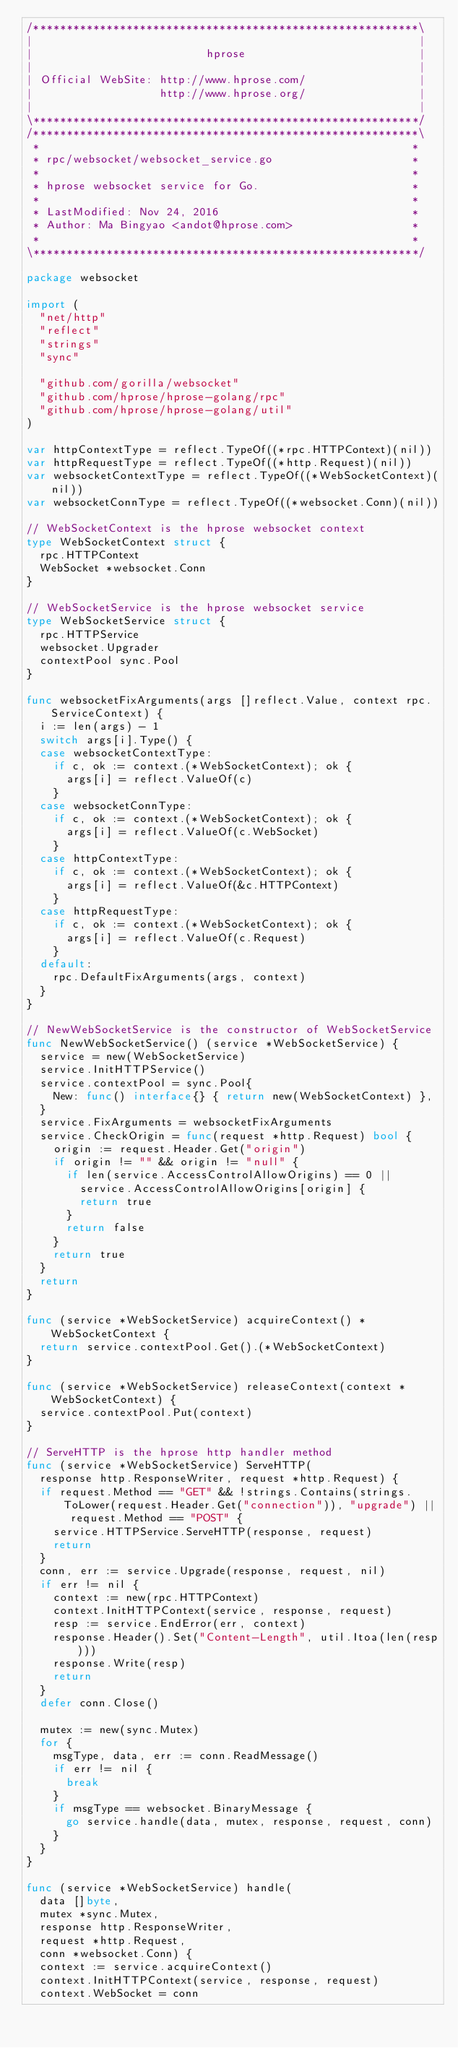<code> <loc_0><loc_0><loc_500><loc_500><_Go_>/**********************************************************\
|                                                          |
|                          hprose                          |
|                                                          |
| Official WebSite: http://www.hprose.com/                 |
|                   http://www.hprose.org/                 |
|                                                          |
\**********************************************************/
/**********************************************************\
 *                                                        *
 * rpc/websocket/websocket_service.go                     *
 *                                                        *
 * hprose websocket service for Go.                       *
 *                                                        *
 * LastModified: Nov 24, 2016                             *
 * Author: Ma Bingyao <andot@hprose.com>                  *
 *                                                        *
\**********************************************************/

package websocket

import (
	"net/http"
	"reflect"
	"strings"
	"sync"

	"github.com/gorilla/websocket"
	"github.com/hprose/hprose-golang/rpc"
	"github.com/hprose/hprose-golang/util"
)

var httpContextType = reflect.TypeOf((*rpc.HTTPContext)(nil))
var httpRequestType = reflect.TypeOf((*http.Request)(nil))
var websocketContextType = reflect.TypeOf((*WebSocketContext)(nil))
var websocketConnType = reflect.TypeOf((*websocket.Conn)(nil))

// WebSocketContext is the hprose websocket context
type WebSocketContext struct {
	rpc.HTTPContext
	WebSocket *websocket.Conn
}

// WebSocketService is the hprose websocket service
type WebSocketService struct {
	rpc.HTTPService
	websocket.Upgrader
	contextPool sync.Pool
}

func websocketFixArguments(args []reflect.Value, context rpc.ServiceContext) {
	i := len(args) - 1
	switch args[i].Type() {
	case websocketContextType:
		if c, ok := context.(*WebSocketContext); ok {
			args[i] = reflect.ValueOf(c)
		}
	case websocketConnType:
		if c, ok := context.(*WebSocketContext); ok {
			args[i] = reflect.ValueOf(c.WebSocket)
		}
	case httpContextType:
		if c, ok := context.(*WebSocketContext); ok {
			args[i] = reflect.ValueOf(&c.HTTPContext)
		}
	case httpRequestType:
		if c, ok := context.(*WebSocketContext); ok {
			args[i] = reflect.ValueOf(c.Request)
		}
	default:
		rpc.DefaultFixArguments(args, context)
	}
}

// NewWebSocketService is the constructor of WebSocketService
func NewWebSocketService() (service *WebSocketService) {
	service = new(WebSocketService)
	service.InitHTTPService()
	service.contextPool = sync.Pool{
		New: func() interface{} { return new(WebSocketContext) },
	}
	service.FixArguments = websocketFixArguments
	service.CheckOrigin = func(request *http.Request) bool {
		origin := request.Header.Get("origin")
		if origin != "" && origin != "null" {
			if len(service.AccessControlAllowOrigins) == 0 ||
				service.AccessControlAllowOrigins[origin] {
				return true
			}
			return false
		}
		return true
	}
	return
}

func (service *WebSocketService) acquireContext() *WebSocketContext {
	return service.contextPool.Get().(*WebSocketContext)
}

func (service *WebSocketService) releaseContext(context *WebSocketContext) {
	service.contextPool.Put(context)
}

// ServeHTTP is the hprose http handler method
func (service *WebSocketService) ServeHTTP(
	response http.ResponseWriter, request *http.Request) {
	if request.Method == "GET" && !strings.Contains(strings.ToLower(request.Header.Get("connection")), "upgrade") || request.Method == "POST" {
		service.HTTPService.ServeHTTP(response, request)
		return
	}
	conn, err := service.Upgrade(response, request, nil)
	if err != nil {
		context := new(rpc.HTTPContext)
		context.InitHTTPContext(service, response, request)
		resp := service.EndError(err, context)
		response.Header().Set("Content-Length", util.Itoa(len(resp)))
		response.Write(resp)
		return
	}
	defer conn.Close()

	mutex := new(sync.Mutex)
	for {
		msgType, data, err := conn.ReadMessage()
		if err != nil {
			break
		}
		if msgType == websocket.BinaryMessage {
			go service.handle(data, mutex, response, request, conn)
		}
	}
}

func (service *WebSocketService) handle(
	data []byte,
	mutex *sync.Mutex,
	response http.ResponseWriter,
	request *http.Request,
	conn *websocket.Conn) {
	context := service.acquireContext()
	context.InitHTTPContext(service, response, request)
	context.WebSocket = conn</code> 